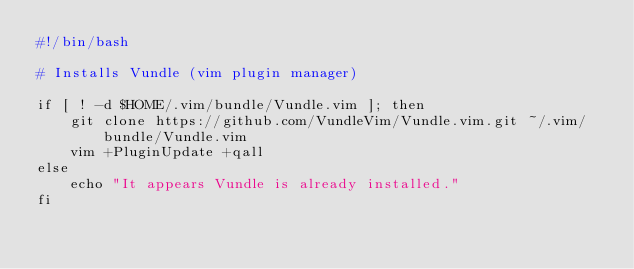Convert code to text. <code><loc_0><loc_0><loc_500><loc_500><_Bash_>#!/bin/bash

# Installs Vundle (vim plugin manager)

if [ ! -d $HOME/.vim/bundle/Vundle.vim ]; then
    git clone https://github.com/VundleVim/Vundle.vim.git ~/.vim/bundle/Vundle.vim
    vim +PluginUpdate +qall
else
    echo "It appears Vundle is already installed."
fi
</code> 